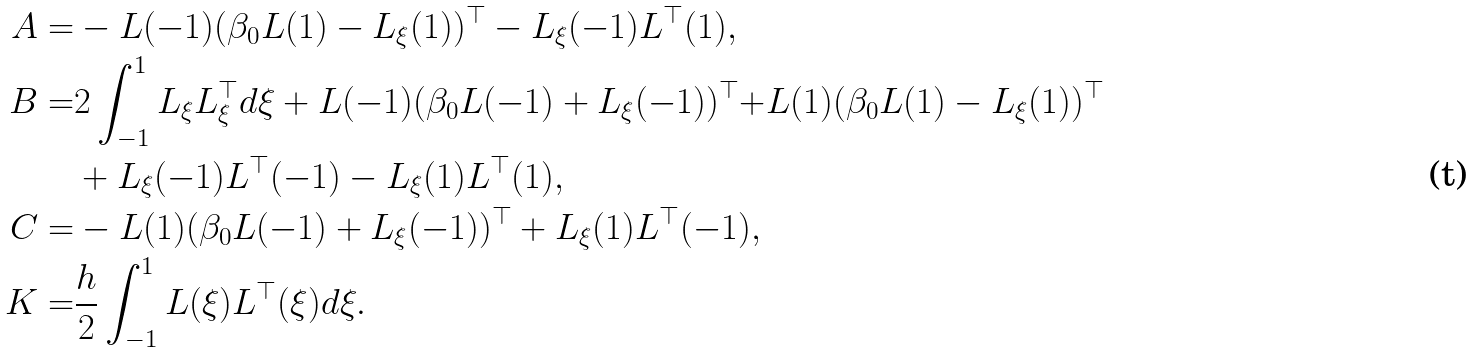<formula> <loc_0><loc_0><loc_500><loc_500>A = & - L ( - 1 ) ( \beta _ { 0 } L ( 1 ) - L _ { \xi } ( 1 ) ) ^ { \top } - L _ { \xi } ( - 1 ) L ^ { \top } ( 1 ) , \\ B = & 2 \int _ { - 1 } ^ { 1 } L _ { \xi } L _ { \xi } ^ { \top } d \xi + L ( - 1 ) ( \beta _ { 0 } L ( - 1 ) + L _ { \xi } ( - 1 ) ) ^ { \top } { + } L ( 1 ) ( \beta _ { 0 } L ( 1 ) - L _ { \xi } ( 1 ) ) ^ { \top } \\ & + L _ { \xi } ( - 1 ) L ^ { \top } ( - 1 ) - L _ { \xi } ( 1 ) L ^ { \top } ( 1 ) , \\ C = & - L ( 1 ) ( \beta _ { 0 } L ( - 1 ) + L _ { \xi } ( - 1 ) ) ^ { \top } + L _ { \xi } ( 1 ) L ^ { \top } ( - 1 ) , \\ K = & \frac { h } { 2 } \int _ { - 1 } ^ { 1 } L ( \xi ) L ^ { \top } ( \xi ) d \xi .</formula> 